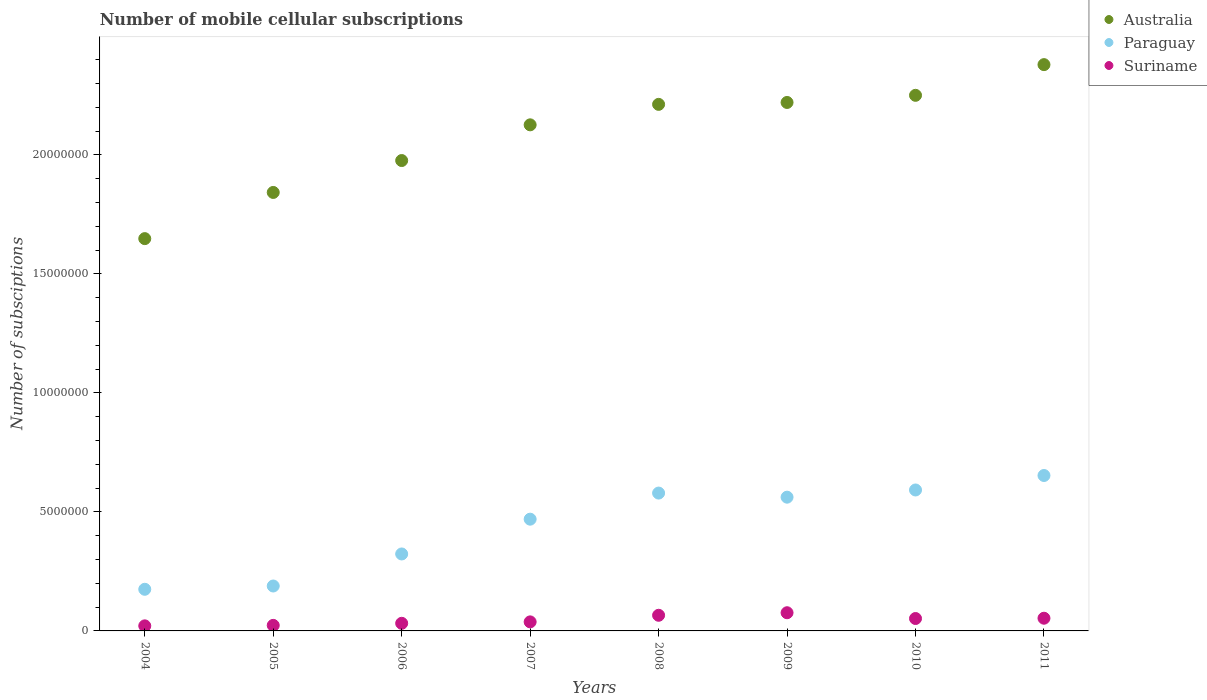What is the number of mobile cellular subscriptions in Suriname in 2009?
Make the answer very short. 7.64e+05. Across all years, what is the maximum number of mobile cellular subscriptions in Paraguay?
Keep it short and to the point. 6.53e+06. Across all years, what is the minimum number of mobile cellular subscriptions in Australia?
Offer a very short reply. 1.65e+07. In which year was the number of mobile cellular subscriptions in Paraguay maximum?
Make the answer very short. 2011. In which year was the number of mobile cellular subscriptions in Australia minimum?
Give a very brief answer. 2004. What is the total number of mobile cellular subscriptions in Paraguay in the graph?
Provide a short and direct response. 3.54e+07. What is the difference between the number of mobile cellular subscriptions in Paraguay in 2005 and that in 2006?
Provide a succinct answer. -1.35e+06. What is the difference between the number of mobile cellular subscriptions in Suriname in 2004 and the number of mobile cellular subscriptions in Australia in 2007?
Ensure brevity in your answer.  -2.10e+07. What is the average number of mobile cellular subscriptions in Paraguay per year?
Your answer should be very brief. 4.43e+06. In the year 2008, what is the difference between the number of mobile cellular subscriptions in Paraguay and number of mobile cellular subscriptions in Suriname?
Ensure brevity in your answer.  5.13e+06. In how many years, is the number of mobile cellular subscriptions in Suriname greater than 16000000?
Offer a terse response. 0. What is the ratio of the number of mobile cellular subscriptions in Paraguay in 2010 to that in 2011?
Keep it short and to the point. 0.91. Is the number of mobile cellular subscriptions in Australia in 2006 less than that in 2007?
Your response must be concise. Yes. Is the difference between the number of mobile cellular subscriptions in Paraguay in 2004 and 2005 greater than the difference between the number of mobile cellular subscriptions in Suriname in 2004 and 2005?
Give a very brief answer. No. What is the difference between the highest and the second highest number of mobile cellular subscriptions in Australia?
Your answer should be very brief. 1.29e+06. What is the difference between the highest and the lowest number of mobile cellular subscriptions in Paraguay?
Make the answer very short. 4.78e+06. Is the sum of the number of mobile cellular subscriptions in Suriname in 2005 and 2009 greater than the maximum number of mobile cellular subscriptions in Australia across all years?
Offer a very short reply. No. Is the number of mobile cellular subscriptions in Australia strictly greater than the number of mobile cellular subscriptions in Paraguay over the years?
Your answer should be compact. Yes. Is the number of mobile cellular subscriptions in Australia strictly less than the number of mobile cellular subscriptions in Suriname over the years?
Give a very brief answer. No. How many years are there in the graph?
Give a very brief answer. 8. What is the difference between two consecutive major ticks on the Y-axis?
Provide a succinct answer. 5.00e+06. Are the values on the major ticks of Y-axis written in scientific E-notation?
Provide a succinct answer. No. Does the graph contain any zero values?
Your answer should be compact. No. Does the graph contain grids?
Ensure brevity in your answer.  No. Where does the legend appear in the graph?
Ensure brevity in your answer.  Top right. How are the legend labels stacked?
Provide a short and direct response. Vertical. What is the title of the graph?
Ensure brevity in your answer.  Number of mobile cellular subscriptions. What is the label or title of the X-axis?
Your answer should be compact. Years. What is the label or title of the Y-axis?
Ensure brevity in your answer.  Number of subsciptions. What is the Number of subsciptions of Australia in 2004?
Provide a short and direct response. 1.65e+07. What is the Number of subsciptions in Paraguay in 2004?
Provide a short and direct response. 1.75e+06. What is the Number of subsciptions of Suriname in 2004?
Offer a terse response. 2.13e+05. What is the Number of subsciptions of Australia in 2005?
Offer a very short reply. 1.84e+07. What is the Number of subsciptions in Paraguay in 2005?
Offer a terse response. 1.89e+06. What is the Number of subsciptions of Suriname in 2005?
Give a very brief answer. 2.33e+05. What is the Number of subsciptions of Australia in 2006?
Your answer should be very brief. 1.98e+07. What is the Number of subsciptions of Paraguay in 2006?
Your answer should be compact. 3.23e+06. What is the Number of subsciptions of Australia in 2007?
Offer a very short reply. 2.13e+07. What is the Number of subsciptions of Paraguay in 2007?
Your response must be concise. 4.69e+06. What is the Number of subsciptions of Suriname in 2007?
Provide a short and direct response. 3.80e+05. What is the Number of subsciptions in Australia in 2008?
Your answer should be very brief. 2.21e+07. What is the Number of subsciptions of Paraguay in 2008?
Your response must be concise. 5.79e+06. What is the Number of subsciptions in Suriname in 2008?
Your answer should be compact. 6.57e+05. What is the Number of subsciptions in Australia in 2009?
Keep it short and to the point. 2.22e+07. What is the Number of subsciptions of Paraguay in 2009?
Offer a very short reply. 5.62e+06. What is the Number of subsciptions of Suriname in 2009?
Offer a very short reply. 7.64e+05. What is the Number of subsciptions in Australia in 2010?
Ensure brevity in your answer.  2.25e+07. What is the Number of subsciptions in Paraguay in 2010?
Provide a short and direct response. 5.92e+06. What is the Number of subsciptions in Suriname in 2010?
Provide a succinct answer. 5.21e+05. What is the Number of subsciptions of Australia in 2011?
Your answer should be very brief. 2.38e+07. What is the Number of subsciptions in Paraguay in 2011?
Keep it short and to the point. 6.53e+06. What is the Number of subsciptions of Suriname in 2011?
Provide a succinct answer. 5.34e+05. Across all years, what is the maximum Number of subsciptions of Australia?
Your answer should be very brief. 2.38e+07. Across all years, what is the maximum Number of subsciptions in Paraguay?
Give a very brief answer. 6.53e+06. Across all years, what is the maximum Number of subsciptions of Suriname?
Offer a terse response. 7.64e+05. Across all years, what is the minimum Number of subsciptions in Australia?
Offer a very short reply. 1.65e+07. Across all years, what is the minimum Number of subsciptions in Paraguay?
Offer a very short reply. 1.75e+06. Across all years, what is the minimum Number of subsciptions of Suriname?
Offer a very short reply. 2.13e+05. What is the total Number of subsciptions of Australia in the graph?
Provide a short and direct response. 1.67e+08. What is the total Number of subsciptions of Paraguay in the graph?
Provide a succinct answer. 3.54e+07. What is the total Number of subsciptions in Suriname in the graph?
Provide a succinct answer. 3.62e+06. What is the difference between the Number of subsciptions of Australia in 2004 and that in 2005?
Your answer should be compact. -1.94e+06. What is the difference between the Number of subsciptions in Paraguay in 2004 and that in 2005?
Ensure brevity in your answer.  -1.38e+05. What is the difference between the Number of subsciptions in Suriname in 2004 and that in 2005?
Make the answer very short. -2.00e+04. What is the difference between the Number of subsciptions of Australia in 2004 and that in 2006?
Your response must be concise. -3.28e+06. What is the difference between the Number of subsciptions of Paraguay in 2004 and that in 2006?
Keep it short and to the point. -1.48e+06. What is the difference between the Number of subsciptions in Suriname in 2004 and that in 2006?
Provide a succinct answer. -1.07e+05. What is the difference between the Number of subsciptions in Australia in 2004 and that in 2007?
Your answer should be very brief. -4.78e+06. What is the difference between the Number of subsciptions in Paraguay in 2004 and that in 2007?
Offer a very short reply. -2.95e+06. What is the difference between the Number of subsciptions in Suriname in 2004 and that in 2007?
Make the answer very short. -1.67e+05. What is the difference between the Number of subsciptions of Australia in 2004 and that in 2008?
Your answer should be very brief. -5.64e+06. What is the difference between the Number of subsciptions of Paraguay in 2004 and that in 2008?
Your response must be concise. -4.04e+06. What is the difference between the Number of subsciptions of Suriname in 2004 and that in 2008?
Offer a very short reply. -4.44e+05. What is the difference between the Number of subsciptions of Australia in 2004 and that in 2009?
Offer a very short reply. -5.72e+06. What is the difference between the Number of subsciptions in Paraguay in 2004 and that in 2009?
Your answer should be very brief. -3.87e+06. What is the difference between the Number of subsciptions of Suriname in 2004 and that in 2009?
Your response must be concise. -5.51e+05. What is the difference between the Number of subsciptions of Australia in 2004 and that in 2010?
Your answer should be very brief. -6.02e+06. What is the difference between the Number of subsciptions of Paraguay in 2004 and that in 2010?
Make the answer very short. -4.17e+06. What is the difference between the Number of subsciptions in Suriname in 2004 and that in 2010?
Provide a succinct answer. -3.08e+05. What is the difference between the Number of subsciptions in Australia in 2004 and that in 2011?
Your answer should be compact. -7.31e+06. What is the difference between the Number of subsciptions of Paraguay in 2004 and that in 2011?
Offer a very short reply. -4.78e+06. What is the difference between the Number of subsciptions in Suriname in 2004 and that in 2011?
Provide a succinct answer. -3.21e+05. What is the difference between the Number of subsciptions in Australia in 2005 and that in 2006?
Your answer should be very brief. -1.34e+06. What is the difference between the Number of subsciptions in Paraguay in 2005 and that in 2006?
Offer a very short reply. -1.35e+06. What is the difference between the Number of subsciptions in Suriname in 2005 and that in 2006?
Your answer should be very brief. -8.72e+04. What is the difference between the Number of subsciptions in Australia in 2005 and that in 2007?
Ensure brevity in your answer.  -2.84e+06. What is the difference between the Number of subsciptions in Paraguay in 2005 and that in 2007?
Offer a very short reply. -2.81e+06. What is the difference between the Number of subsciptions in Suriname in 2005 and that in 2007?
Keep it short and to the point. -1.47e+05. What is the difference between the Number of subsciptions in Australia in 2005 and that in 2008?
Offer a very short reply. -3.70e+06. What is the difference between the Number of subsciptions of Paraguay in 2005 and that in 2008?
Provide a succinct answer. -3.90e+06. What is the difference between the Number of subsciptions of Suriname in 2005 and that in 2008?
Provide a short and direct response. -4.24e+05. What is the difference between the Number of subsciptions of Australia in 2005 and that in 2009?
Your answer should be very brief. -3.78e+06. What is the difference between the Number of subsciptions of Paraguay in 2005 and that in 2009?
Your response must be concise. -3.73e+06. What is the difference between the Number of subsciptions of Suriname in 2005 and that in 2009?
Your answer should be compact. -5.31e+05. What is the difference between the Number of subsciptions of Australia in 2005 and that in 2010?
Offer a very short reply. -4.08e+06. What is the difference between the Number of subsciptions in Paraguay in 2005 and that in 2010?
Offer a very short reply. -4.03e+06. What is the difference between the Number of subsciptions in Suriname in 2005 and that in 2010?
Your answer should be compact. -2.88e+05. What is the difference between the Number of subsciptions in Australia in 2005 and that in 2011?
Ensure brevity in your answer.  -5.37e+06. What is the difference between the Number of subsciptions in Paraguay in 2005 and that in 2011?
Ensure brevity in your answer.  -4.64e+06. What is the difference between the Number of subsciptions of Suriname in 2005 and that in 2011?
Offer a very short reply. -3.01e+05. What is the difference between the Number of subsciptions in Australia in 2006 and that in 2007?
Offer a terse response. -1.50e+06. What is the difference between the Number of subsciptions in Paraguay in 2006 and that in 2007?
Offer a terse response. -1.46e+06. What is the difference between the Number of subsciptions in Suriname in 2006 and that in 2007?
Your answer should be compact. -6.00e+04. What is the difference between the Number of subsciptions of Australia in 2006 and that in 2008?
Provide a succinct answer. -2.36e+06. What is the difference between the Number of subsciptions in Paraguay in 2006 and that in 2008?
Ensure brevity in your answer.  -2.56e+06. What is the difference between the Number of subsciptions of Suriname in 2006 and that in 2008?
Keep it short and to the point. -3.37e+05. What is the difference between the Number of subsciptions in Australia in 2006 and that in 2009?
Ensure brevity in your answer.  -2.44e+06. What is the difference between the Number of subsciptions in Paraguay in 2006 and that in 2009?
Ensure brevity in your answer.  -2.39e+06. What is the difference between the Number of subsciptions of Suriname in 2006 and that in 2009?
Provide a succinct answer. -4.44e+05. What is the difference between the Number of subsciptions of Australia in 2006 and that in 2010?
Provide a short and direct response. -2.74e+06. What is the difference between the Number of subsciptions of Paraguay in 2006 and that in 2010?
Your answer should be compact. -2.69e+06. What is the difference between the Number of subsciptions of Suriname in 2006 and that in 2010?
Provide a succinct answer. -2.01e+05. What is the difference between the Number of subsciptions in Australia in 2006 and that in 2011?
Offer a terse response. -4.03e+06. What is the difference between the Number of subsciptions in Paraguay in 2006 and that in 2011?
Keep it short and to the point. -3.30e+06. What is the difference between the Number of subsciptions of Suriname in 2006 and that in 2011?
Offer a terse response. -2.14e+05. What is the difference between the Number of subsciptions in Australia in 2007 and that in 2008?
Your answer should be very brief. -8.60e+05. What is the difference between the Number of subsciptions in Paraguay in 2007 and that in 2008?
Provide a succinct answer. -1.10e+06. What is the difference between the Number of subsciptions in Suriname in 2007 and that in 2008?
Give a very brief answer. -2.77e+05. What is the difference between the Number of subsciptions in Australia in 2007 and that in 2009?
Make the answer very short. -9.40e+05. What is the difference between the Number of subsciptions of Paraguay in 2007 and that in 2009?
Offer a terse response. -9.24e+05. What is the difference between the Number of subsciptions in Suriname in 2007 and that in 2009?
Keep it short and to the point. -3.84e+05. What is the difference between the Number of subsciptions in Australia in 2007 and that in 2010?
Your answer should be very brief. -1.24e+06. What is the difference between the Number of subsciptions in Paraguay in 2007 and that in 2010?
Offer a very short reply. -1.23e+06. What is the difference between the Number of subsciptions in Suriname in 2007 and that in 2010?
Provide a short and direct response. -1.41e+05. What is the difference between the Number of subsciptions of Australia in 2007 and that in 2011?
Ensure brevity in your answer.  -2.53e+06. What is the difference between the Number of subsciptions in Paraguay in 2007 and that in 2011?
Make the answer very short. -1.83e+06. What is the difference between the Number of subsciptions of Suriname in 2007 and that in 2011?
Your response must be concise. -1.54e+05. What is the difference between the Number of subsciptions in Paraguay in 2008 and that in 2009?
Provide a short and direct response. 1.72e+05. What is the difference between the Number of subsciptions of Suriname in 2008 and that in 2009?
Your answer should be very brief. -1.07e+05. What is the difference between the Number of subsciptions in Australia in 2008 and that in 2010?
Your answer should be compact. -3.80e+05. What is the difference between the Number of subsciptions of Paraguay in 2008 and that in 2010?
Make the answer very short. -1.30e+05. What is the difference between the Number of subsciptions of Suriname in 2008 and that in 2010?
Make the answer very short. 1.36e+05. What is the difference between the Number of subsciptions of Australia in 2008 and that in 2011?
Your answer should be compact. -1.67e+06. What is the difference between the Number of subsciptions in Paraguay in 2008 and that in 2011?
Provide a short and direct response. -7.38e+05. What is the difference between the Number of subsciptions of Suriname in 2008 and that in 2011?
Provide a short and direct response. 1.24e+05. What is the difference between the Number of subsciptions of Australia in 2009 and that in 2010?
Offer a very short reply. -3.00e+05. What is the difference between the Number of subsciptions of Paraguay in 2009 and that in 2010?
Your answer should be very brief. -3.02e+05. What is the difference between the Number of subsciptions of Suriname in 2009 and that in 2010?
Keep it short and to the point. 2.43e+05. What is the difference between the Number of subsciptions of Australia in 2009 and that in 2011?
Ensure brevity in your answer.  -1.59e+06. What is the difference between the Number of subsciptions of Paraguay in 2009 and that in 2011?
Offer a terse response. -9.10e+05. What is the difference between the Number of subsciptions in Suriname in 2009 and that in 2011?
Provide a succinct answer. 2.30e+05. What is the difference between the Number of subsciptions of Australia in 2010 and that in 2011?
Provide a succinct answer. -1.29e+06. What is the difference between the Number of subsciptions in Paraguay in 2010 and that in 2011?
Provide a succinct answer. -6.08e+05. What is the difference between the Number of subsciptions of Suriname in 2010 and that in 2011?
Keep it short and to the point. -1.24e+04. What is the difference between the Number of subsciptions in Australia in 2004 and the Number of subsciptions in Paraguay in 2005?
Provide a succinct answer. 1.46e+07. What is the difference between the Number of subsciptions in Australia in 2004 and the Number of subsciptions in Suriname in 2005?
Keep it short and to the point. 1.62e+07. What is the difference between the Number of subsciptions in Paraguay in 2004 and the Number of subsciptions in Suriname in 2005?
Your answer should be very brief. 1.52e+06. What is the difference between the Number of subsciptions of Australia in 2004 and the Number of subsciptions of Paraguay in 2006?
Offer a terse response. 1.32e+07. What is the difference between the Number of subsciptions in Australia in 2004 and the Number of subsciptions in Suriname in 2006?
Your response must be concise. 1.62e+07. What is the difference between the Number of subsciptions in Paraguay in 2004 and the Number of subsciptions in Suriname in 2006?
Offer a very short reply. 1.43e+06. What is the difference between the Number of subsciptions of Australia in 2004 and the Number of subsciptions of Paraguay in 2007?
Give a very brief answer. 1.18e+07. What is the difference between the Number of subsciptions in Australia in 2004 and the Number of subsciptions in Suriname in 2007?
Offer a terse response. 1.61e+07. What is the difference between the Number of subsciptions in Paraguay in 2004 and the Number of subsciptions in Suriname in 2007?
Provide a short and direct response. 1.37e+06. What is the difference between the Number of subsciptions in Australia in 2004 and the Number of subsciptions in Paraguay in 2008?
Offer a terse response. 1.07e+07. What is the difference between the Number of subsciptions of Australia in 2004 and the Number of subsciptions of Suriname in 2008?
Offer a terse response. 1.58e+07. What is the difference between the Number of subsciptions in Paraguay in 2004 and the Number of subsciptions in Suriname in 2008?
Ensure brevity in your answer.  1.09e+06. What is the difference between the Number of subsciptions in Australia in 2004 and the Number of subsciptions in Paraguay in 2009?
Provide a succinct answer. 1.09e+07. What is the difference between the Number of subsciptions in Australia in 2004 and the Number of subsciptions in Suriname in 2009?
Ensure brevity in your answer.  1.57e+07. What is the difference between the Number of subsciptions of Paraguay in 2004 and the Number of subsciptions of Suriname in 2009?
Provide a short and direct response. 9.85e+05. What is the difference between the Number of subsciptions of Australia in 2004 and the Number of subsciptions of Paraguay in 2010?
Offer a terse response. 1.06e+07. What is the difference between the Number of subsciptions in Australia in 2004 and the Number of subsciptions in Suriname in 2010?
Your answer should be compact. 1.60e+07. What is the difference between the Number of subsciptions of Paraguay in 2004 and the Number of subsciptions of Suriname in 2010?
Provide a short and direct response. 1.23e+06. What is the difference between the Number of subsciptions of Australia in 2004 and the Number of subsciptions of Paraguay in 2011?
Provide a succinct answer. 9.95e+06. What is the difference between the Number of subsciptions in Australia in 2004 and the Number of subsciptions in Suriname in 2011?
Provide a succinct answer. 1.59e+07. What is the difference between the Number of subsciptions of Paraguay in 2004 and the Number of subsciptions of Suriname in 2011?
Give a very brief answer. 1.22e+06. What is the difference between the Number of subsciptions of Australia in 2005 and the Number of subsciptions of Paraguay in 2006?
Offer a very short reply. 1.52e+07. What is the difference between the Number of subsciptions of Australia in 2005 and the Number of subsciptions of Suriname in 2006?
Provide a succinct answer. 1.81e+07. What is the difference between the Number of subsciptions of Paraguay in 2005 and the Number of subsciptions of Suriname in 2006?
Give a very brief answer. 1.57e+06. What is the difference between the Number of subsciptions in Australia in 2005 and the Number of subsciptions in Paraguay in 2007?
Your answer should be compact. 1.37e+07. What is the difference between the Number of subsciptions in Australia in 2005 and the Number of subsciptions in Suriname in 2007?
Your answer should be very brief. 1.80e+07. What is the difference between the Number of subsciptions in Paraguay in 2005 and the Number of subsciptions in Suriname in 2007?
Offer a very short reply. 1.51e+06. What is the difference between the Number of subsciptions of Australia in 2005 and the Number of subsciptions of Paraguay in 2008?
Offer a very short reply. 1.26e+07. What is the difference between the Number of subsciptions of Australia in 2005 and the Number of subsciptions of Suriname in 2008?
Your response must be concise. 1.78e+07. What is the difference between the Number of subsciptions of Paraguay in 2005 and the Number of subsciptions of Suriname in 2008?
Offer a very short reply. 1.23e+06. What is the difference between the Number of subsciptions of Australia in 2005 and the Number of subsciptions of Paraguay in 2009?
Offer a terse response. 1.28e+07. What is the difference between the Number of subsciptions of Australia in 2005 and the Number of subsciptions of Suriname in 2009?
Provide a short and direct response. 1.77e+07. What is the difference between the Number of subsciptions in Paraguay in 2005 and the Number of subsciptions in Suriname in 2009?
Your answer should be compact. 1.12e+06. What is the difference between the Number of subsciptions of Australia in 2005 and the Number of subsciptions of Paraguay in 2010?
Your response must be concise. 1.25e+07. What is the difference between the Number of subsciptions in Australia in 2005 and the Number of subsciptions in Suriname in 2010?
Your answer should be very brief. 1.79e+07. What is the difference between the Number of subsciptions of Paraguay in 2005 and the Number of subsciptions of Suriname in 2010?
Your answer should be compact. 1.37e+06. What is the difference between the Number of subsciptions in Australia in 2005 and the Number of subsciptions in Paraguay in 2011?
Your answer should be very brief. 1.19e+07. What is the difference between the Number of subsciptions of Australia in 2005 and the Number of subsciptions of Suriname in 2011?
Provide a short and direct response. 1.79e+07. What is the difference between the Number of subsciptions in Paraguay in 2005 and the Number of subsciptions in Suriname in 2011?
Make the answer very short. 1.35e+06. What is the difference between the Number of subsciptions in Australia in 2006 and the Number of subsciptions in Paraguay in 2007?
Offer a very short reply. 1.51e+07. What is the difference between the Number of subsciptions in Australia in 2006 and the Number of subsciptions in Suriname in 2007?
Ensure brevity in your answer.  1.94e+07. What is the difference between the Number of subsciptions of Paraguay in 2006 and the Number of subsciptions of Suriname in 2007?
Make the answer very short. 2.85e+06. What is the difference between the Number of subsciptions in Australia in 2006 and the Number of subsciptions in Paraguay in 2008?
Your response must be concise. 1.40e+07. What is the difference between the Number of subsciptions of Australia in 2006 and the Number of subsciptions of Suriname in 2008?
Keep it short and to the point. 1.91e+07. What is the difference between the Number of subsciptions of Paraguay in 2006 and the Number of subsciptions of Suriname in 2008?
Your response must be concise. 2.58e+06. What is the difference between the Number of subsciptions of Australia in 2006 and the Number of subsciptions of Paraguay in 2009?
Give a very brief answer. 1.41e+07. What is the difference between the Number of subsciptions of Australia in 2006 and the Number of subsciptions of Suriname in 2009?
Ensure brevity in your answer.  1.90e+07. What is the difference between the Number of subsciptions in Paraguay in 2006 and the Number of subsciptions in Suriname in 2009?
Your answer should be very brief. 2.47e+06. What is the difference between the Number of subsciptions in Australia in 2006 and the Number of subsciptions in Paraguay in 2010?
Provide a short and direct response. 1.38e+07. What is the difference between the Number of subsciptions in Australia in 2006 and the Number of subsciptions in Suriname in 2010?
Keep it short and to the point. 1.92e+07. What is the difference between the Number of subsciptions in Paraguay in 2006 and the Number of subsciptions in Suriname in 2010?
Provide a short and direct response. 2.71e+06. What is the difference between the Number of subsciptions of Australia in 2006 and the Number of subsciptions of Paraguay in 2011?
Your answer should be compact. 1.32e+07. What is the difference between the Number of subsciptions in Australia in 2006 and the Number of subsciptions in Suriname in 2011?
Ensure brevity in your answer.  1.92e+07. What is the difference between the Number of subsciptions of Paraguay in 2006 and the Number of subsciptions of Suriname in 2011?
Your answer should be compact. 2.70e+06. What is the difference between the Number of subsciptions of Australia in 2007 and the Number of subsciptions of Paraguay in 2008?
Make the answer very short. 1.55e+07. What is the difference between the Number of subsciptions of Australia in 2007 and the Number of subsciptions of Suriname in 2008?
Your answer should be compact. 2.06e+07. What is the difference between the Number of subsciptions in Paraguay in 2007 and the Number of subsciptions in Suriname in 2008?
Keep it short and to the point. 4.04e+06. What is the difference between the Number of subsciptions of Australia in 2007 and the Number of subsciptions of Paraguay in 2009?
Keep it short and to the point. 1.56e+07. What is the difference between the Number of subsciptions of Australia in 2007 and the Number of subsciptions of Suriname in 2009?
Give a very brief answer. 2.05e+07. What is the difference between the Number of subsciptions in Paraguay in 2007 and the Number of subsciptions in Suriname in 2009?
Offer a very short reply. 3.93e+06. What is the difference between the Number of subsciptions of Australia in 2007 and the Number of subsciptions of Paraguay in 2010?
Give a very brief answer. 1.53e+07. What is the difference between the Number of subsciptions of Australia in 2007 and the Number of subsciptions of Suriname in 2010?
Your response must be concise. 2.07e+07. What is the difference between the Number of subsciptions in Paraguay in 2007 and the Number of subsciptions in Suriname in 2010?
Keep it short and to the point. 4.17e+06. What is the difference between the Number of subsciptions of Australia in 2007 and the Number of subsciptions of Paraguay in 2011?
Your answer should be very brief. 1.47e+07. What is the difference between the Number of subsciptions in Australia in 2007 and the Number of subsciptions in Suriname in 2011?
Give a very brief answer. 2.07e+07. What is the difference between the Number of subsciptions in Paraguay in 2007 and the Number of subsciptions in Suriname in 2011?
Your answer should be very brief. 4.16e+06. What is the difference between the Number of subsciptions in Australia in 2008 and the Number of subsciptions in Paraguay in 2009?
Offer a very short reply. 1.65e+07. What is the difference between the Number of subsciptions in Australia in 2008 and the Number of subsciptions in Suriname in 2009?
Ensure brevity in your answer.  2.14e+07. What is the difference between the Number of subsciptions of Paraguay in 2008 and the Number of subsciptions of Suriname in 2009?
Give a very brief answer. 5.03e+06. What is the difference between the Number of subsciptions of Australia in 2008 and the Number of subsciptions of Paraguay in 2010?
Keep it short and to the point. 1.62e+07. What is the difference between the Number of subsciptions in Australia in 2008 and the Number of subsciptions in Suriname in 2010?
Ensure brevity in your answer.  2.16e+07. What is the difference between the Number of subsciptions of Paraguay in 2008 and the Number of subsciptions of Suriname in 2010?
Your answer should be very brief. 5.27e+06. What is the difference between the Number of subsciptions in Australia in 2008 and the Number of subsciptions in Paraguay in 2011?
Ensure brevity in your answer.  1.56e+07. What is the difference between the Number of subsciptions in Australia in 2008 and the Number of subsciptions in Suriname in 2011?
Offer a terse response. 2.16e+07. What is the difference between the Number of subsciptions in Paraguay in 2008 and the Number of subsciptions in Suriname in 2011?
Your response must be concise. 5.26e+06. What is the difference between the Number of subsciptions in Australia in 2009 and the Number of subsciptions in Paraguay in 2010?
Your answer should be compact. 1.63e+07. What is the difference between the Number of subsciptions in Australia in 2009 and the Number of subsciptions in Suriname in 2010?
Your answer should be compact. 2.17e+07. What is the difference between the Number of subsciptions of Paraguay in 2009 and the Number of subsciptions of Suriname in 2010?
Give a very brief answer. 5.10e+06. What is the difference between the Number of subsciptions in Australia in 2009 and the Number of subsciptions in Paraguay in 2011?
Your answer should be very brief. 1.57e+07. What is the difference between the Number of subsciptions in Australia in 2009 and the Number of subsciptions in Suriname in 2011?
Provide a short and direct response. 2.17e+07. What is the difference between the Number of subsciptions of Paraguay in 2009 and the Number of subsciptions of Suriname in 2011?
Your response must be concise. 5.09e+06. What is the difference between the Number of subsciptions in Australia in 2010 and the Number of subsciptions in Paraguay in 2011?
Your answer should be very brief. 1.60e+07. What is the difference between the Number of subsciptions of Australia in 2010 and the Number of subsciptions of Suriname in 2011?
Your answer should be very brief. 2.20e+07. What is the difference between the Number of subsciptions in Paraguay in 2010 and the Number of subsciptions in Suriname in 2011?
Offer a terse response. 5.39e+06. What is the average Number of subsciptions of Australia per year?
Your response must be concise. 2.08e+07. What is the average Number of subsciptions of Paraguay per year?
Offer a very short reply. 4.43e+06. What is the average Number of subsciptions of Suriname per year?
Keep it short and to the point. 4.53e+05. In the year 2004, what is the difference between the Number of subsciptions in Australia and Number of subsciptions in Paraguay?
Offer a very short reply. 1.47e+07. In the year 2004, what is the difference between the Number of subsciptions in Australia and Number of subsciptions in Suriname?
Your answer should be very brief. 1.63e+07. In the year 2004, what is the difference between the Number of subsciptions of Paraguay and Number of subsciptions of Suriname?
Your answer should be very brief. 1.54e+06. In the year 2005, what is the difference between the Number of subsciptions of Australia and Number of subsciptions of Paraguay?
Provide a short and direct response. 1.65e+07. In the year 2005, what is the difference between the Number of subsciptions of Australia and Number of subsciptions of Suriname?
Keep it short and to the point. 1.82e+07. In the year 2005, what is the difference between the Number of subsciptions of Paraguay and Number of subsciptions of Suriname?
Provide a short and direct response. 1.65e+06. In the year 2006, what is the difference between the Number of subsciptions in Australia and Number of subsciptions in Paraguay?
Make the answer very short. 1.65e+07. In the year 2006, what is the difference between the Number of subsciptions in Australia and Number of subsciptions in Suriname?
Ensure brevity in your answer.  1.94e+07. In the year 2006, what is the difference between the Number of subsciptions in Paraguay and Number of subsciptions in Suriname?
Provide a succinct answer. 2.91e+06. In the year 2007, what is the difference between the Number of subsciptions of Australia and Number of subsciptions of Paraguay?
Provide a succinct answer. 1.66e+07. In the year 2007, what is the difference between the Number of subsciptions of Australia and Number of subsciptions of Suriname?
Offer a very short reply. 2.09e+07. In the year 2007, what is the difference between the Number of subsciptions in Paraguay and Number of subsciptions in Suriname?
Your response must be concise. 4.31e+06. In the year 2008, what is the difference between the Number of subsciptions in Australia and Number of subsciptions in Paraguay?
Ensure brevity in your answer.  1.63e+07. In the year 2008, what is the difference between the Number of subsciptions of Australia and Number of subsciptions of Suriname?
Make the answer very short. 2.15e+07. In the year 2008, what is the difference between the Number of subsciptions of Paraguay and Number of subsciptions of Suriname?
Provide a succinct answer. 5.13e+06. In the year 2009, what is the difference between the Number of subsciptions of Australia and Number of subsciptions of Paraguay?
Give a very brief answer. 1.66e+07. In the year 2009, what is the difference between the Number of subsciptions of Australia and Number of subsciptions of Suriname?
Ensure brevity in your answer.  2.14e+07. In the year 2009, what is the difference between the Number of subsciptions in Paraguay and Number of subsciptions in Suriname?
Your answer should be compact. 4.85e+06. In the year 2010, what is the difference between the Number of subsciptions of Australia and Number of subsciptions of Paraguay?
Offer a terse response. 1.66e+07. In the year 2010, what is the difference between the Number of subsciptions in Australia and Number of subsciptions in Suriname?
Your answer should be very brief. 2.20e+07. In the year 2010, what is the difference between the Number of subsciptions of Paraguay and Number of subsciptions of Suriname?
Your response must be concise. 5.40e+06. In the year 2011, what is the difference between the Number of subsciptions in Australia and Number of subsciptions in Paraguay?
Your answer should be compact. 1.73e+07. In the year 2011, what is the difference between the Number of subsciptions of Australia and Number of subsciptions of Suriname?
Ensure brevity in your answer.  2.33e+07. In the year 2011, what is the difference between the Number of subsciptions in Paraguay and Number of subsciptions in Suriname?
Give a very brief answer. 6.00e+06. What is the ratio of the Number of subsciptions in Australia in 2004 to that in 2005?
Offer a very short reply. 0.89. What is the ratio of the Number of subsciptions of Paraguay in 2004 to that in 2005?
Keep it short and to the point. 0.93. What is the ratio of the Number of subsciptions of Suriname in 2004 to that in 2005?
Provide a short and direct response. 0.91. What is the ratio of the Number of subsciptions of Australia in 2004 to that in 2006?
Provide a short and direct response. 0.83. What is the ratio of the Number of subsciptions in Paraguay in 2004 to that in 2006?
Make the answer very short. 0.54. What is the ratio of the Number of subsciptions of Suriname in 2004 to that in 2006?
Your answer should be very brief. 0.67. What is the ratio of the Number of subsciptions in Australia in 2004 to that in 2007?
Make the answer very short. 0.78. What is the ratio of the Number of subsciptions in Paraguay in 2004 to that in 2007?
Ensure brevity in your answer.  0.37. What is the ratio of the Number of subsciptions in Suriname in 2004 to that in 2007?
Your answer should be very brief. 0.56. What is the ratio of the Number of subsciptions of Australia in 2004 to that in 2008?
Provide a short and direct response. 0.74. What is the ratio of the Number of subsciptions of Paraguay in 2004 to that in 2008?
Offer a very short reply. 0.3. What is the ratio of the Number of subsciptions in Suriname in 2004 to that in 2008?
Provide a succinct answer. 0.32. What is the ratio of the Number of subsciptions in Australia in 2004 to that in 2009?
Give a very brief answer. 0.74. What is the ratio of the Number of subsciptions in Paraguay in 2004 to that in 2009?
Keep it short and to the point. 0.31. What is the ratio of the Number of subsciptions of Suriname in 2004 to that in 2009?
Offer a very short reply. 0.28. What is the ratio of the Number of subsciptions in Australia in 2004 to that in 2010?
Make the answer very short. 0.73. What is the ratio of the Number of subsciptions of Paraguay in 2004 to that in 2010?
Provide a short and direct response. 0.3. What is the ratio of the Number of subsciptions in Suriname in 2004 to that in 2010?
Offer a very short reply. 0.41. What is the ratio of the Number of subsciptions in Australia in 2004 to that in 2011?
Keep it short and to the point. 0.69. What is the ratio of the Number of subsciptions in Paraguay in 2004 to that in 2011?
Make the answer very short. 0.27. What is the ratio of the Number of subsciptions of Suriname in 2004 to that in 2011?
Your answer should be very brief. 0.4. What is the ratio of the Number of subsciptions of Australia in 2005 to that in 2006?
Your answer should be very brief. 0.93. What is the ratio of the Number of subsciptions in Paraguay in 2005 to that in 2006?
Ensure brevity in your answer.  0.58. What is the ratio of the Number of subsciptions in Suriname in 2005 to that in 2006?
Your answer should be compact. 0.73. What is the ratio of the Number of subsciptions of Australia in 2005 to that in 2007?
Ensure brevity in your answer.  0.87. What is the ratio of the Number of subsciptions of Paraguay in 2005 to that in 2007?
Your response must be concise. 0.4. What is the ratio of the Number of subsciptions of Suriname in 2005 to that in 2007?
Provide a succinct answer. 0.61. What is the ratio of the Number of subsciptions in Australia in 2005 to that in 2008?
Offer a very short reply. 0.83. What is the ratio of the Number of subsciptions in Paraguay in 2005 to that in 2008?
Keep it short and to the point. 0.33. What is the ratio of the Number of subsciptions in Suriname in 2005 to that in 2008?
Your answer should be compact. 0.35. What is the ratio of the Number of subsciptions in Australia in 2005 to that in 2009?
Your answer should be compact. 0.83. What is the ratio of the Number of subsciptions of Paraguay in 2005 to that in 2009?
Your response must be concise. 0.34. What is the ratio of the Number of subsciptions in Suriname in 2005 to that in 2009?
Offer a very short reply. 0.3. What is the ratio of the Number of subsciptions in Australia in 2005 to that in 2010?
Offer a very short reply. 0.82. What is the ratio of the Number of subsciptions in Paraguay in 2005 to that in 2010?
Provide a succinct answer. 0.32. What is the ratio of the Number of subsciptions of Suriname in 2005 to that in 2010?
Make the answer very short. 0.45. What is the ratio of the Number of subsciptions of Australia in 2005 to that in 2011?
Your answer should be compact. 0.77. What is the ratio of the Number of subsciptions in Paraguay in 2005 to that in 2011?
Your answer should be compact. 0.29. What is the ratio of the Number of subsciptions in Suriname in 2005 to that in 2011?
Give a very brief answer. 0.44. What is the ratio of the Number of subsciptions of Australia in 2006 to that in 2007?
Offer a very short reply. 0.93. What is the ratio of the Number of subsciptions in Paraguay in 2006 to that in 2007?
Provide a succinct answer. 0.69. What is the ratio of the Number of subsciptions in Suriname in 2006 to that in 2007?
Provide a succinct answer. 0.84. What is the ratio of the Number of subsciptions in Australia in 2006 to that in 2008?
Your answer should be compact. 0.89. What is the ratio of the Number of subsciptions in Paraguay in 2006 to that in 2008?
Ensure brevity in your answer.  0.56. What is the ratio of the Number of subsciptions in Suriname in 2006 to that in 2008?
Provide a short and direct response. 0.49. What is the ratio of the Number of subsciptions in Australia in 2006 to that in 2009?
Your answer should be very brief. 0.89. What is the ratio of the Number of subsciptions of Paraguay in 2006 to that in 2009?
Keep it short and to the point. 0.58. What is the ratio of the Number of subsciptions in Suriname in 2006 to that in 2009?
Offer a terse response. 0.42. What is the ratio of the Number of subsciptions in Australia in 2006 to that in 2010?
Your response must be concise. 0.88. What is the ratio of the Number of subsciptions of Paraguay in 2006 to that in 2010?
Offer a very short reply. 0.55. What is the ratio of the Number of subsciptions in Suriname in 2006 to that in 2010?
Provide a short and direct response. 0.61. What is the ratio of the Number of subsciptions of Australia in 2006 to that in 2011?
Offer a very short reply. 0.83. What is the ratio of the Number of subsciptions in Paraguay in 2006 to that in 2011?
Ensure brevity in your answer.  0.5. What is the ratio of the Number of subsciptions of Suriname in 2006 to that in 2011?
Provide a short and direct response. 0.6. What is the ratio of the Number of subsciptions of Australia in 2007 to that in 2008?
Your response must be concise. 0.96. What is the ratio of the Number of subsciptions of Paraguay in 2007 to that in 2008?
Keep it short and to the point. 0.81. What is the ratio of the Number of subsciptions of Suriname in 2007 to that in 2008?
Provide a succinct answer. 0.58. What is the ratio of the Number of subsciptions of Australia in 2007 to that in 2009?
Your answer should be compact. 0.96. What is the ratio of the Number of subsciptions in Paraguay in 2007 to that in 2009?
Offer a very short reply. 0.84. What is the ratio of the Number of subsciptions of Suriname in 2007 to that in 2009?
Provide a short and direct response. 0.5. What is the ratio of the Number of subsciptions of Australia in 2007 to that in 2010?
Provide a short and direct response. 0.94. What is the ratio of the Number of subsciptions in Paraguay in 2007 to that in 2010?
Offer a terse response. 0.79. What is the ratio of the Number of subsciptions of Suriname in 2007 to that in 2010?
Provide a short and direct response. 0.73. What is the ratio of the Number of subsciptions of Australia in 2007 to that in 2011?
Give a very brief answer. 0.89. What is the ratio of the Number of subsciptions of Paraguay in 2007 to that in 2011?
Ensure brevity in your answer.  0.72. What is the ratio of the Number of subsciptions in Suriname in 2007 to that in 2011?
Provide a succinct answer. 0.71. What is the ratio of the Number of subsciptions in Paraguay in 2008 to that in 2009?
Your answer should be very brief. 1.03. What is the ratio of the Number of subsciptions of Suriname in 2008 to that in 2009?
Keep it short and to the point. 0.86. What is the ratio of the Number of subsciptions of Australia in 2008 to that in 2010?
Offer a very short reply. 0.98. What is the ratio of the Number of subsciptions of Suriname in 2008 to that in 2010?
Give a very brief answer. 1.26. What is the ratio of the Number of subsciptions of Australia in 2008 to that in 2011?
Your response must be concise. 0.93. What is the ratio of the Number of subsciptions of Paraguay in 2008 to that in 2011?
Offer a very short reply. 0.89. What is the ratio of the Number of subsciptions in Suriname in 2008 to that in 2011?
Ensure brevity in your answer.  1.23. What is the ratio of the Number of subsciptions of Australia in 2009 to that in 2010?
Keep it short and to the point. 0.99. What is the ratio of the Number of subsciptions in Paraguay in 2009 to that in 2010?
Give a very brief answer. 0.95. What is the ratio of the Number of subsciptions in Suriname in 2009 to that in 2010?
Make the answer very short. 1.47. What is the ratio of the Number of subsciptions in Australia in 2009 to that in 2011?
Make the answer very short. 0.93. What is the ratio of the Number of subsciptions in Paraguay in 2009 to that in 2011?
Keep it short and to the point. 0.86. What is the ratio of the Number of subsciptions in Suriname in 2009 to that in 2011?
Offer a terse response. 1.43. What is the ratio of the Number of subsciptions in Australia in 2010 to that in 2011?
Your answer should be compact. 0.95. What is the ratio of the Number of subsciptions of Paraguay in 2010 to that in 2011?
Provide a short and direct response. 0.91. What is the ratio of the Number of subsciptions in Suriname in 2010 to that in 2011?
Make the answer very short. 0.98. What is the difference between the highest and the second highest Number of subsciptions of Australia?
Your answer should be compact. 1.29e+06. What is the difference between the highest and the second highest Number of subsciptions in Paraguay?
Your response must be concise. 6.08e+05. What is the difference between the highest and the second highest Number of subsciptions in Suriname?
Your answer should be very brief. 1.07e+05. What is the difference between the highest and the lowest Number of subsciptions of Australia?
Provide a short and direct response. 7.31e+06. What is the difference between the highest and the lowest Number of subsciptions of Paraguay?
Make the answer very short. 4.78e+06. What is the difference between the highest and the lowest Number of subsciptions of Suriname?
Your response must be concise. 5.51e+05. 